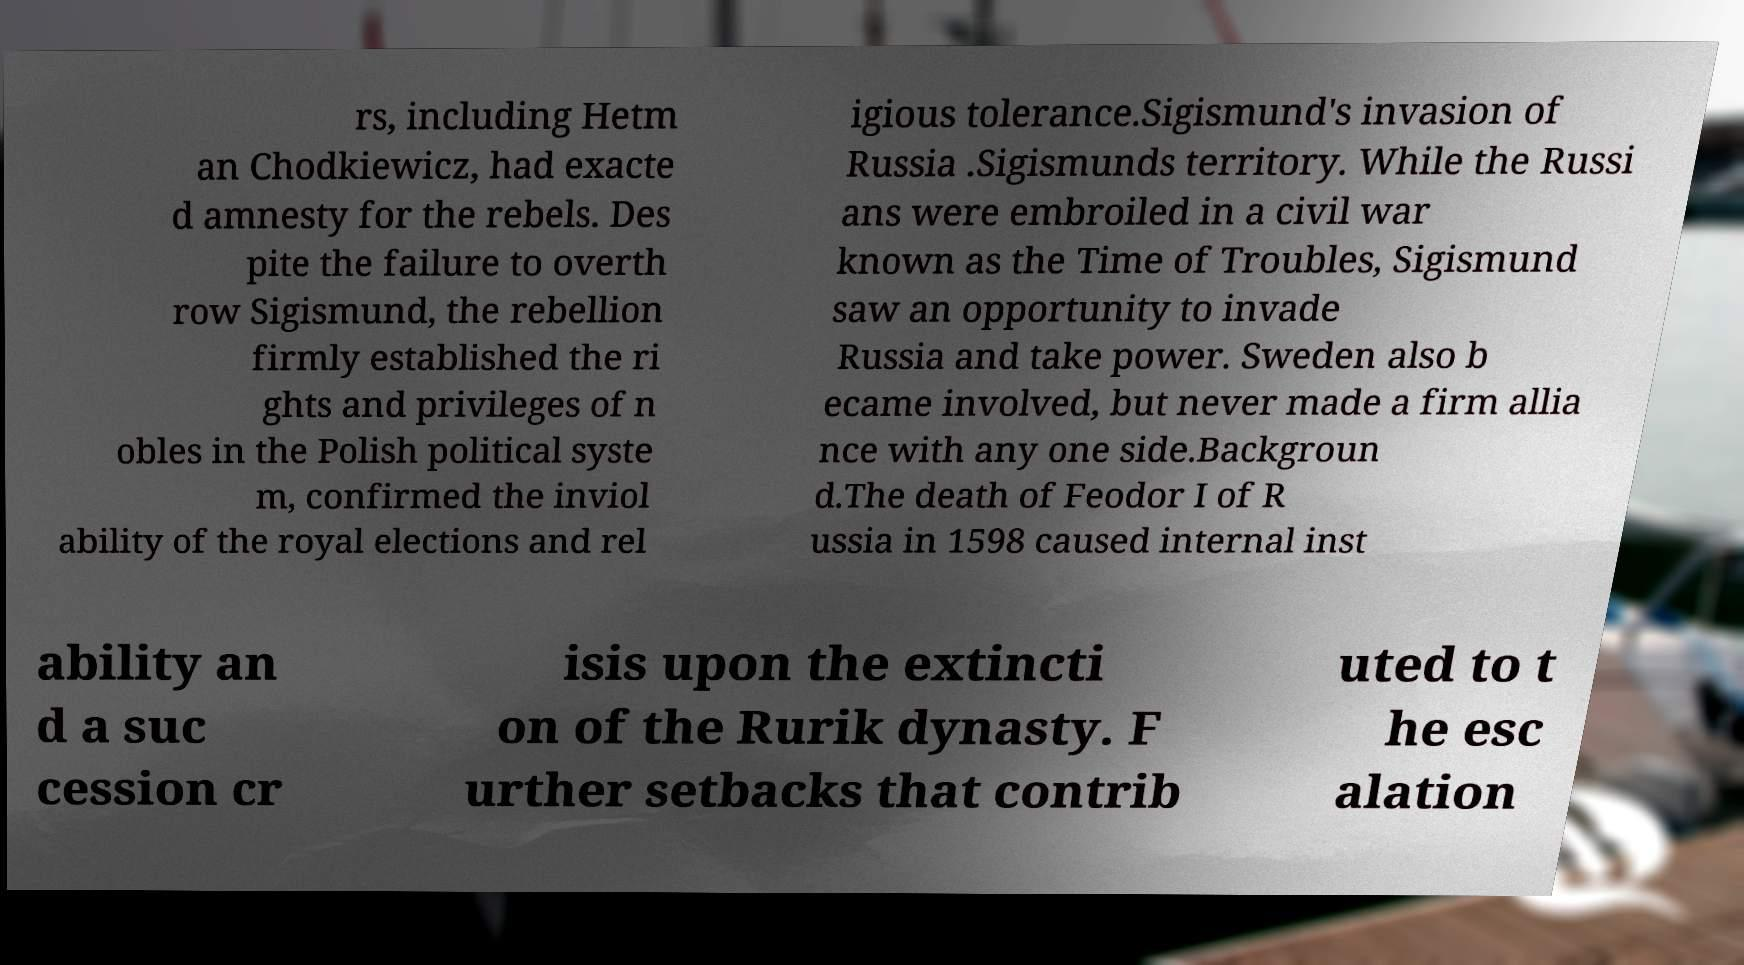There's text embedded in this image that I need extracted. Can you transcribe it verbatim? rs, including Hetm an Chodkiewicz, had exacte d amnesty for the rebels. Des pite the failure to overth row Sigismund, the rebellion firmly established the ri ghts and privileges of n obles in the Polish political syste m, confirmed the inviol ability of the royal elections and rel igious tolerance.Sigismund's invasion of Russia .Sigismunds territory. While the Russi ans were embroiled in a civil war known as the Time of Troubles, Sigismund saw an opportunity to invade Russia and take power. Sweden also b ecame involved, but never made a firm allia nce with any one side.Backgroun d.The death of Feodor I of R ussia in 1598 caused internal inst ability an d a suc cession cr isis upon the extincti on of the Rurik dynasty. F urther setbacks that contrib uted to t he esc alation 